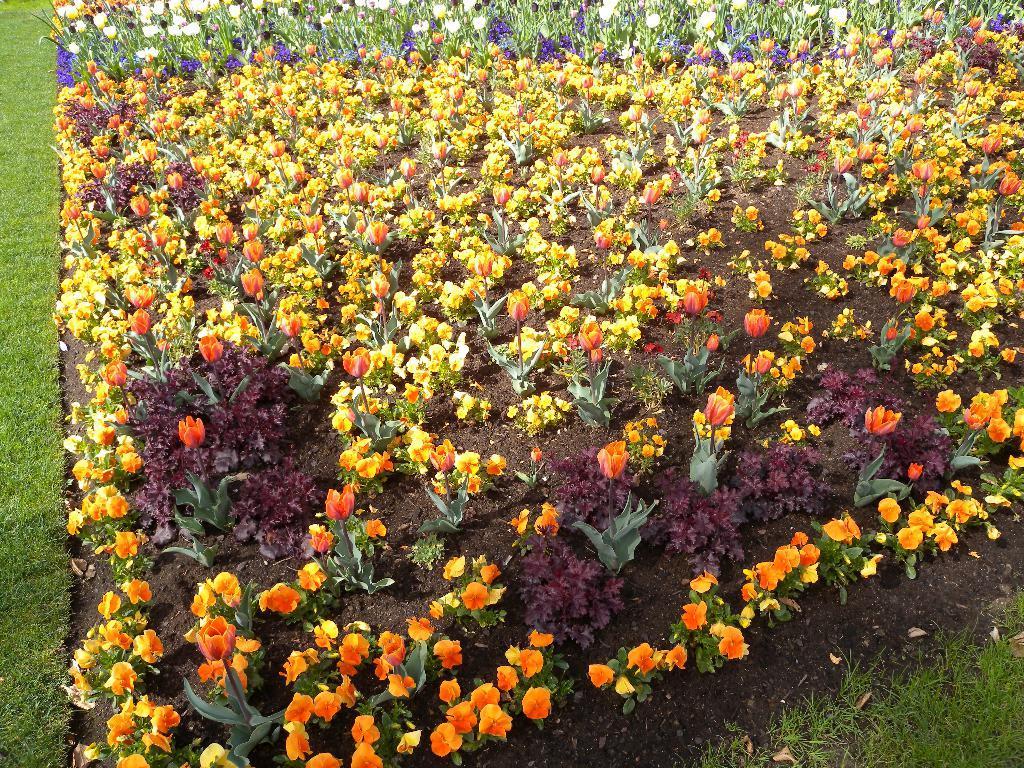Please provide a concise description of this image. In this picture we can see few plants, grass and flowers. 